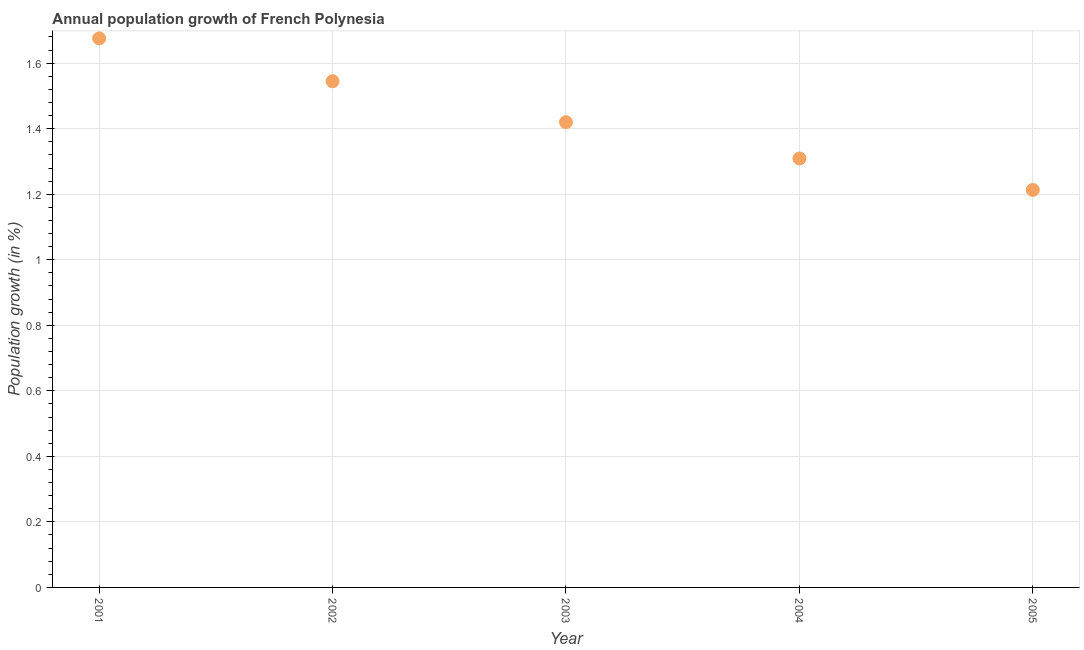What is the population growth in 2001?
Give a very brief answer. 1.68. Across all years, what is the maximum population growth?
Provide a short and direct response. 1.68. Across all years, what is the minimum population growth?
Ensure brevity in your answer.  1.21. In which year was the population growth minimum?
Make the answer very short. 2005. What is the sum of the population growth?
Keep it short and to the point. 7.16. What is the difference between the population growth in 2004 and 2005?
Ensure brevity in your answer.  0.1. What is the average population growth per year?
Offer a terse response. 1.43. What is the median population growth?
Offer a very short reply. 1.42. What is the ratio of the population growth in 2001 to that in 2003?
Provide a succinct answer. 1.18. What is the difference between the highest and the second highest population growth?
Your response must be concise. 0.13. What is the difference between the highest and the lowest population growth?
Provide a short and direct response. 0.46. In how many years, is the population growth greater than the average population growth taken over all years?
Give a very brief answer. 2. Does the population growth monotonically increase over the years?
Your answer should be very brief. No. How many dotlines are there?
Offer a very short reply. 1. What is the difference between two consecutive major ticks on the Y-axis?
Provide a succinct answer. 0.2. Are the values on the major ticks of Y-axis written in scientific E-notation?
Provide a short and direct response. No. Does the graph contain any zero values?
Offer a very short reply. No. What is the title of the graph?
Your answer should be compact. Annual population growth of French Polynesia. What is the label or title of the Y-axis?
Your answer should be very brief. Population growth (in %). What is the Population growth (in %) in 2001?
Make the answer very short. 1.68. What is the Population growth (in %) in 2002?
Offer a terse response. 1.54. What is the Population growth (in %) in 2003?
Keep it short and to the point. 1.42. What is the Population growth (in %) in 2004?
Provide a short and direct response. 1.31. What is the Population growth (in %) in 2005?
Make the answer very short. 1.21. What is the difference between the Population growth (in %) in 2001 and 2002?
Your answer should be very brief. 0.13. What is the difference between the Population growth (in %) in 2001 and 2003?
Make the answer very short. 0.26. What is the difference between the Population growth (in %) in 2001 and 2004?
Your response must be concise. 0.37. What is the difference between the Population growth (in %) in 2001 and 2005?
Provide a succinct answer. 0.46. What is the difference between the Population growth (in %) in 2002 and 2003?
Keep it short and to the point. 0.12. What is the difference between the Population growth (in %) in 2002 and 2004?
Give a very brief answer. 0.24. What is the difference between the Population growth (in %) in 2002 and 2005?
Offer a terse response. 0.33. What is the difference between the Population growth (in %) in 2003 and 2004?
Your answer should be very brief. 0.11. What is the difference between the Population growth (in %) in 2003 and 2005?
Offer a terse response. 0.21. What is the difference between the Population growth (in %) in 2004 and 2005?
Offer a very short reply. 0.1. What is the ratio of the Population growth (in %) in 2001 to that in 2002?
Keep it short and to the point. 1.08. What is the ratio of the Population growth (in %) in 2001 to that in 2003?
Provide a short and direct response. 1.18. What is the ratio of the Population growth (in %) in 2001 to that in 2004?
Provide a succinct answer. 1.28. What is the ratio of the Population growth (in %) in 2001 to that in 2005?
Provide a succinct answer. 1.38. What is the ratio of the Population growth (in %) in 2002 to that in 2003?
Provide a succinct answer. 1.09. What is the ratio of the Population growth (in %) in 2002 to that in 2004?
Your response must be concise. 1.18. What is the ratio of the Population growth (in %) in 2002 to that in 2005?
Give a very brief answer. 1.27. What is the ratio of the Population growth (in %) in 2003 to that in 2004?
Offer a very short reply. 1.08. What is the ratio of the Population growth (in %) in 2003 to that in 2005?
Ensure brevity in your answer.  1.17. What is the ratio of the Population growth (in %) in 2004 to that in 2005?
Keep it short and to the point. 1.08. 